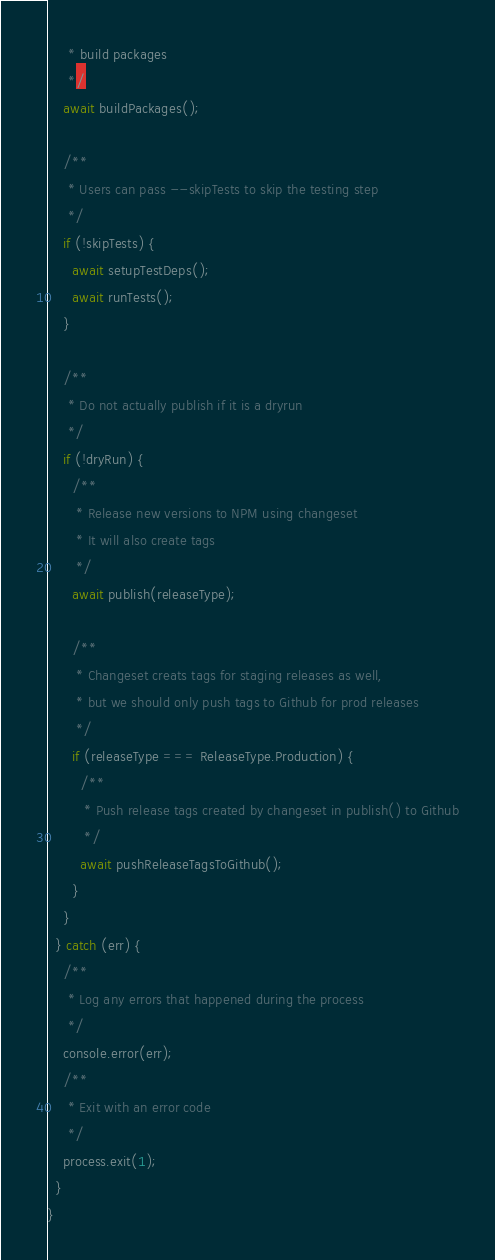Convert code to text. <code><loc_0><loc_0><loc_500><loc_500><_TypeScript_>     * build packages
     */
    await buildPackages();

    /**
     * Users can pass --skipTests to skip the testing step
     */
    if (!skipTests) {
      await setupTestDeps();
      await runTests();
    }

    /**
     * Do not actually publish if it is a dryrun
     */
    if (!dryRun) {
      /**
       * Release new versions to NPM using changeset
       * It will also create tags
       */
      await publish(releaseType);

      /**
       * Changeset creats tags for staging releases as well,
       * but we should only push tags to Github for prod releases
       */
      if (releaseType === ReleaseType.Production) {
        /**
         * Push release tags created by changeset in publish() to Github
         */
        await pushReleaseTagsToGithub();
      }
    }
  } catch (err) {
    /**
     * Log any errors that happened during the process
     */
    console.error(err);
    /**
     * Exit with an error code
     */
    process.exit(1);
  }
}
</code> 